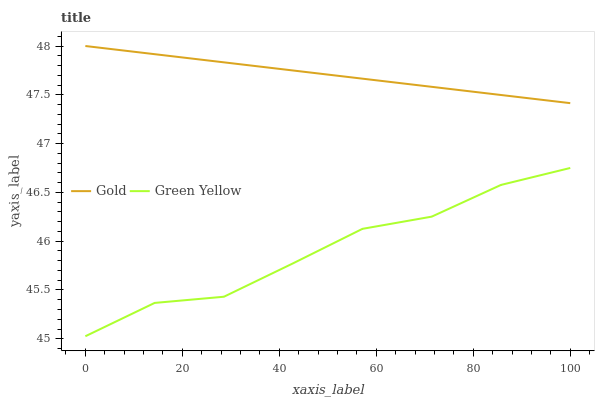Does Green Yellow have the minimum area under the curve?
Answer yes or no. Yes. Does Gold have the maximum area under the curve?
Answer yes or no. Yes. Does Gold have the minimum area under the curve?
Answer yes or no. No. Is Gold the smoothest?
Answer yes or no. Yes. Is Green Yellow the roughest?
Answer yes or no. Yes. Is Gold the roughest?
Answer yes or no. No. Does Green Yellow have the lowest value?
Answer yes or no. Yes. Does Gold have the lowest value?
Answer yes or no. No. Does Gold have the highest value?
Answer yes or no. Yes. Is Green Yellow less than Gold?
Answer yes or no. Yes. Is Gold greater than Green Yellow?
Answer yes or no. Yes. Does Green Yellow intersect Gold?
Answer yes or no. No. 